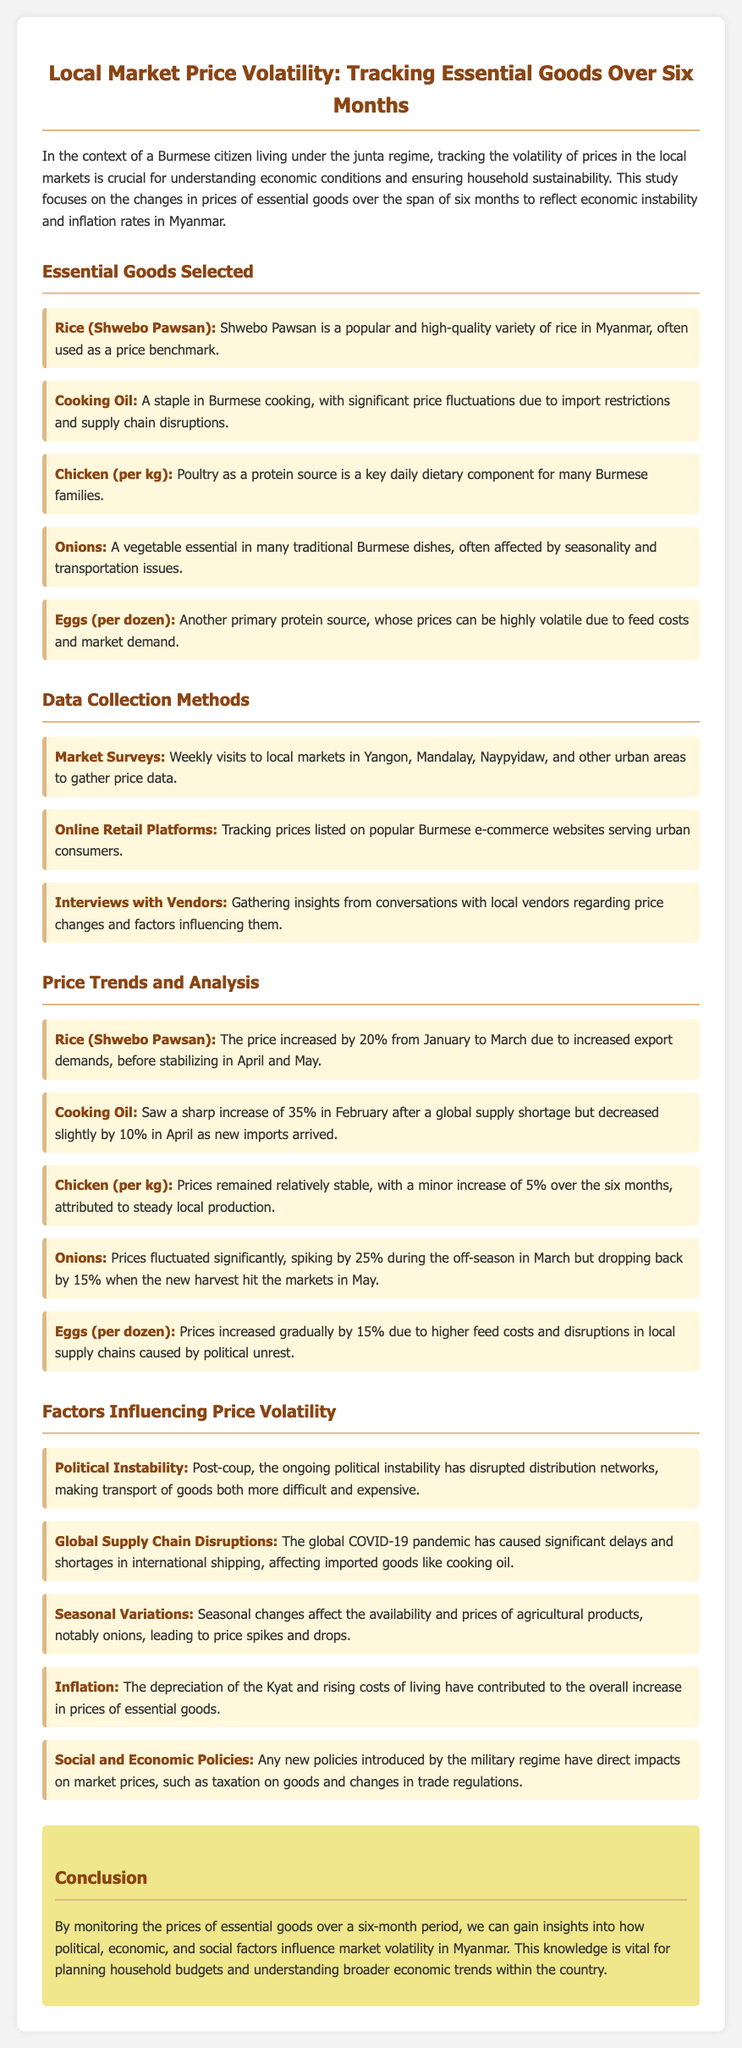What is the main focus of the study? The study focuses on changes in prices of essential goods over six months to reflect economic instability and inflation rates in Myanmar.
Answer: Economic instability and inflation rates What essential good experienced a price increase of 20% from January to March? The price increase of 20% is specifically noted for Shwebo Pawsan rice in the document.
Answer: Rice (Shwebo Pawsan) Which essential good had a price spike of 25% during the off-season? The document states that onions had a significant price spike during the off-season in March.
Answer: Onions What data collection method involved gathering insights from local vendors? One method mentioned is gathering insights through interviews with local vendors regarding price changes.
Answer: Interviews with Vendors What was the increase in price for cooking oil in February? The document specifies that cooking oil saw a sharp increase of 35% in February.
Answer: 35% How did the price of chicken (per kg) change over the six months? Chicken prices remained relatively stable with a minor increase of 5% noted in the document.
Answer: Minor increase of 5% What factor is identified as influencing price volatility related to political conditions? The document mentions political instability as a reason that has disrupted distribution networks.
Answer: Political Instability What percentage did egg prices increase due to higher feed costs? The document states that egg prices increased gradually by 15% due to higher feed costs.
Answer: 15% What economic consequence is caused by the depreciation of the Kyat? The document relates the depreciation of the Kyat to rising overall prices of essential goods in Myanmar.
Answer: Overall price increase 